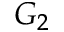<formula> <loc_0><loc_0><loc_500><loc_500>G _ { 2 }</formula> 